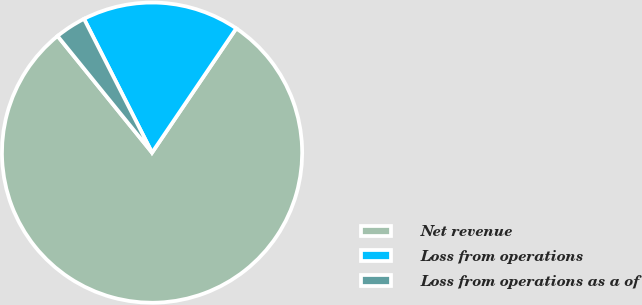Convert chart to OTSL. <chart><loc_0><loc_0><loc_500><loc_500><pie_chart><fcel>Net revenue<fcel>Loss from operations<fcel>Loss from operations as a of<nl><fcel>79.68%<fcel>16.97%<fcel>3.35%<nl></chart> 